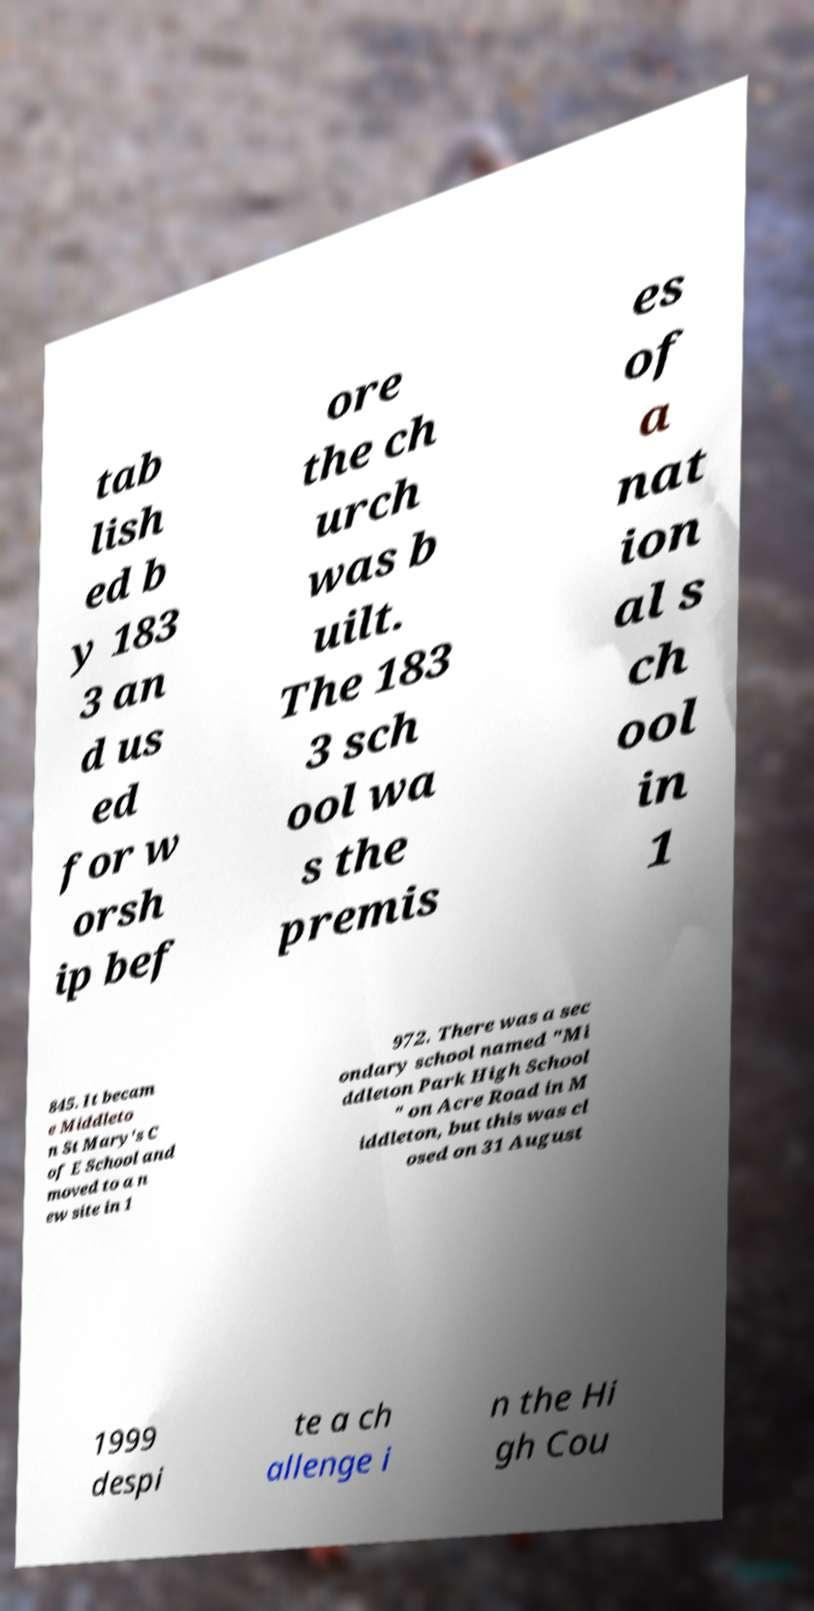Could you extract and type out the text from this image? tab lish ed b y 183 3 an d us ed for w orsh ip bef ore the ch urch was b uilt. The 183 3 sch ool wa s the premis es of a nat ion al s ch ool in 1 845. It becam e Middleto n St Mary's C of E School and moved to a n ew site in 1 972. There was a sec ondary school named "Mi ddleton Park High School " on Acre Road in M iddleton, but this was cl osed on 31 August 1999 despi te a ch allenge i n the Hi gh Cou 